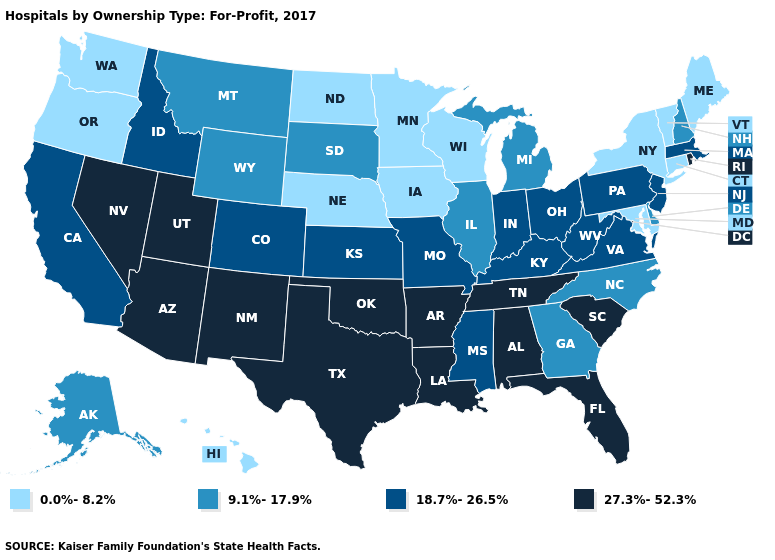What is the highest value in the South ?
Be succinct. 27.3%-52.3%. Name the states that have a value in the range 27.3%-52.3%?
Quick response, please. Alabama, Arizona, Arkansas, Florida, Louisiana, Nevada, New Mexico, Oklahoma, Rhode Island, South Carolina, Tennessee, Texas, Utah. Does the map have missing data?
Keep it brief. No. Among the states that border Nevada , which have the lowest value?
Write a very short answer. Oregon. How many symbols are there in the legend?
Concise answer only. 4. Does the map have missing data?
Keep it brief. No. Which states have the lowest value in the West?
Be succinct. Hawaii, Oregon, Washington. What is the lowest value in states that border Kentucky?
Keep it brief. 9.1%-17.9%. Does Oklahoma have the highest value in the USA?
Quick response, please. Yes. What is the highest value in states that border Texas?
Keep it brief. 27.3%-52.3%. Among the states that border Montana , does South Dakota have the lowest value?
Give a very brief answer. No. Name the states that have a value in the range 18.7%-26.5%?
Write a very short answer. California, Colorado, Idaho, Indiana, Kansas, Kentucky, Massachusetts, Mississippi, Missouri, New Jersey, Ohio, Pennsylvania, Virginia, West Virginia. What is the value of Washington?
Be succinct. 0.0%-8.2%. Name the states that have a value in the range 9.1%-17.9%?
Answer briefly. Alaska, Delaware, Georgia, Illinois, Michigan, Montana, New Hampshire, North Carolina, South Dakota, Wyoming. Does Maine have the lowest value in the USA?
Give a very brief answer. Yes. 